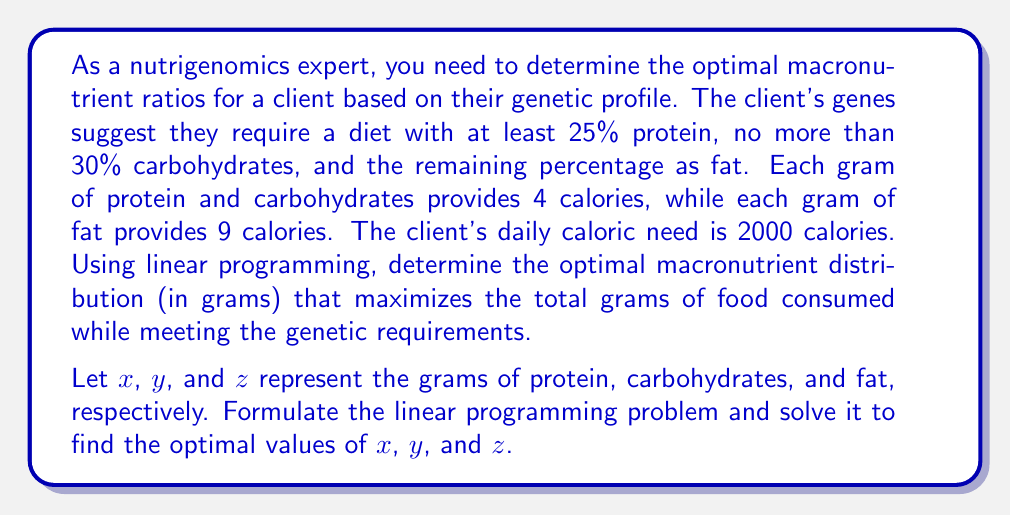Can you solve this math problem? To solve this problem using linear programming, we need to follow these steps:

1. Define the objective function
2. Identify the constraints
3. Set up the linear programming problem
4. Solve the problem

Step 1: Define the objective function

We want to maximize the total grams of food consumed, so our objective function is:
$$\text{Maximize } f(x, y, z) = x + y + z$$

Step 2: Identify the constraints

a) Protein requirement (at least 25% of total calories):
$$4x \geq 0.25 \cdot 2000$$

b) Carbohydrate limit (no more than 30% of total calories):
$$4y \leq 0.30 \cdot 2000$$

c) Total calorie requirement:
$$4x + 4y + 9z = 2000$$

d) Non-negativity constraints:
$$x \geq 0, y \geq 0, z \geq 0$$

Step 3: Set up the linear programming problem

$$\begin{align*}
\text{Maximize: } & x + y + z \\
\text{Subject to: } & 4x \geq 500 \\
& 4y \leq 600 \\
& 4x + 4y + 9z = 2000 \\
& x, y, z \geq 0
\end{align*}$$

Step 4: Solve the problem

To solve this problem, we can use the simplex method or a linear programming solver. However, we can also solve it analytically by considering the constraints:

1. From the protein constraint: $x \geq 125$
2. From the carbohydrate constraint: $y \leq 150$
3. To maximize the total grams, we should use the maximum allowed carbohydrates: $y = 150$

Now, substituting these values into the total calorie constraint:

$$4(125) + 4(150) + 9z = 2000$$
$$500 + 600 + 9z = 2000$$
$$9z = 900$$
$$z = 100$$

To check if this satisfies the protein constraint:
$$4x = 4(125) = 500 = 25\% \text{ of } 2000$$

Therefore, the optimal solution is:
$$x = 125, y = 150, z = 100$$
Answer: The optimal macronutrient distribution is:
Protein: 125 grams
Carbohydrates: 150 grams
Fat: 100 grams 